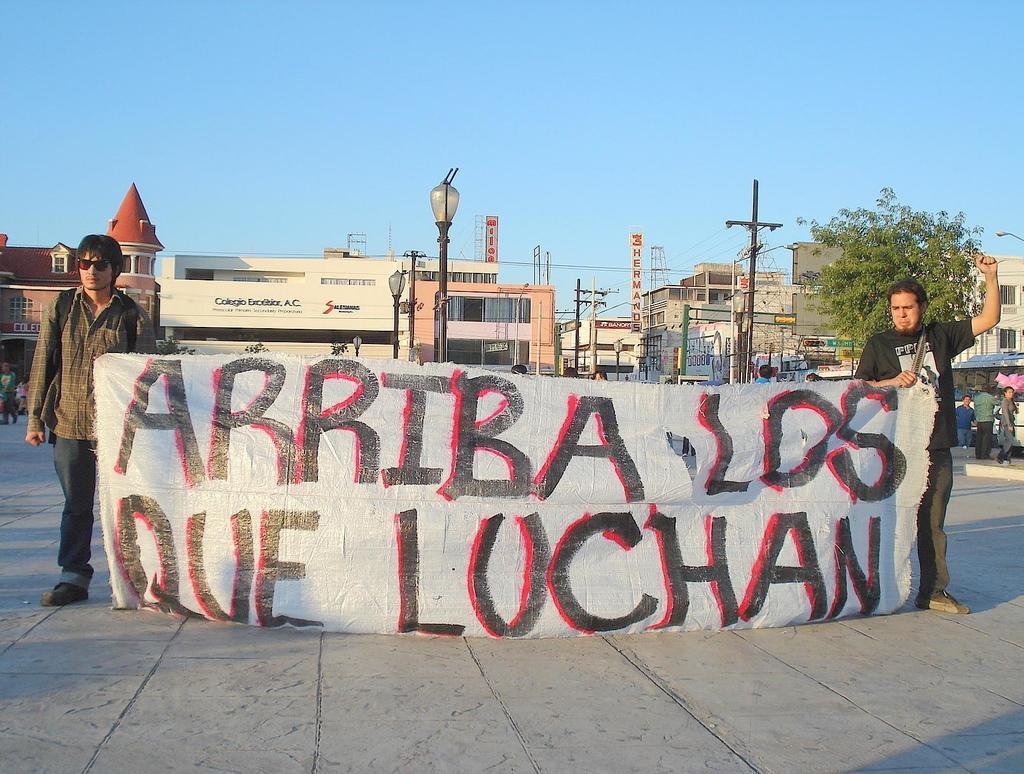Can you describe this image briefly? In the image there are two people standing in the front and holding a banner, there is some text on that banner and behind them there are many buildings and around the buildings there are pole lights and current wire poles, on the right side there is a tree. 